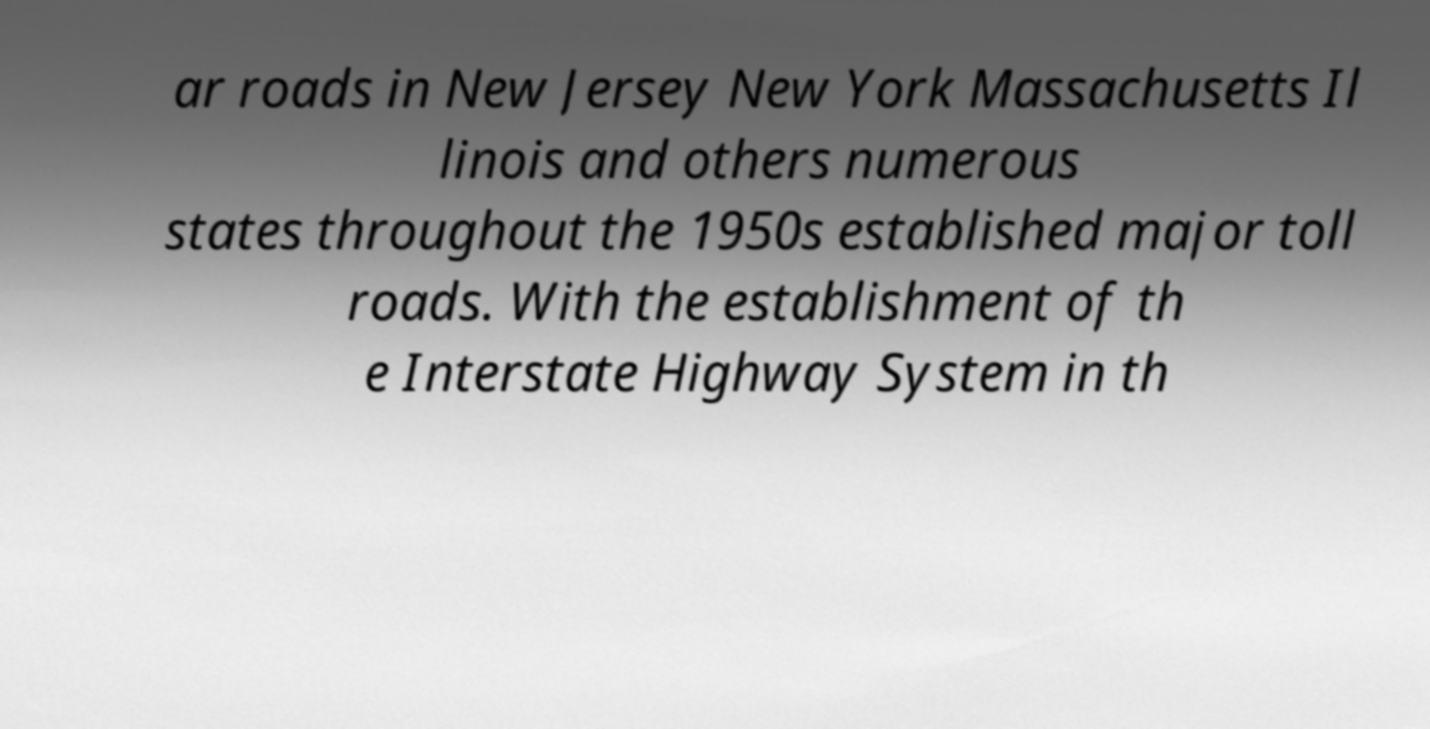Can you read and provide the text displayed in the image?This photo seems to have some interesting text. Can you extract and type it out for me? ar roads in New Jersey New York Massachusetts Il linois and others numerous states throughout the 1950s established major toll roads. With the establishment of th e Interstate Highway System in th 